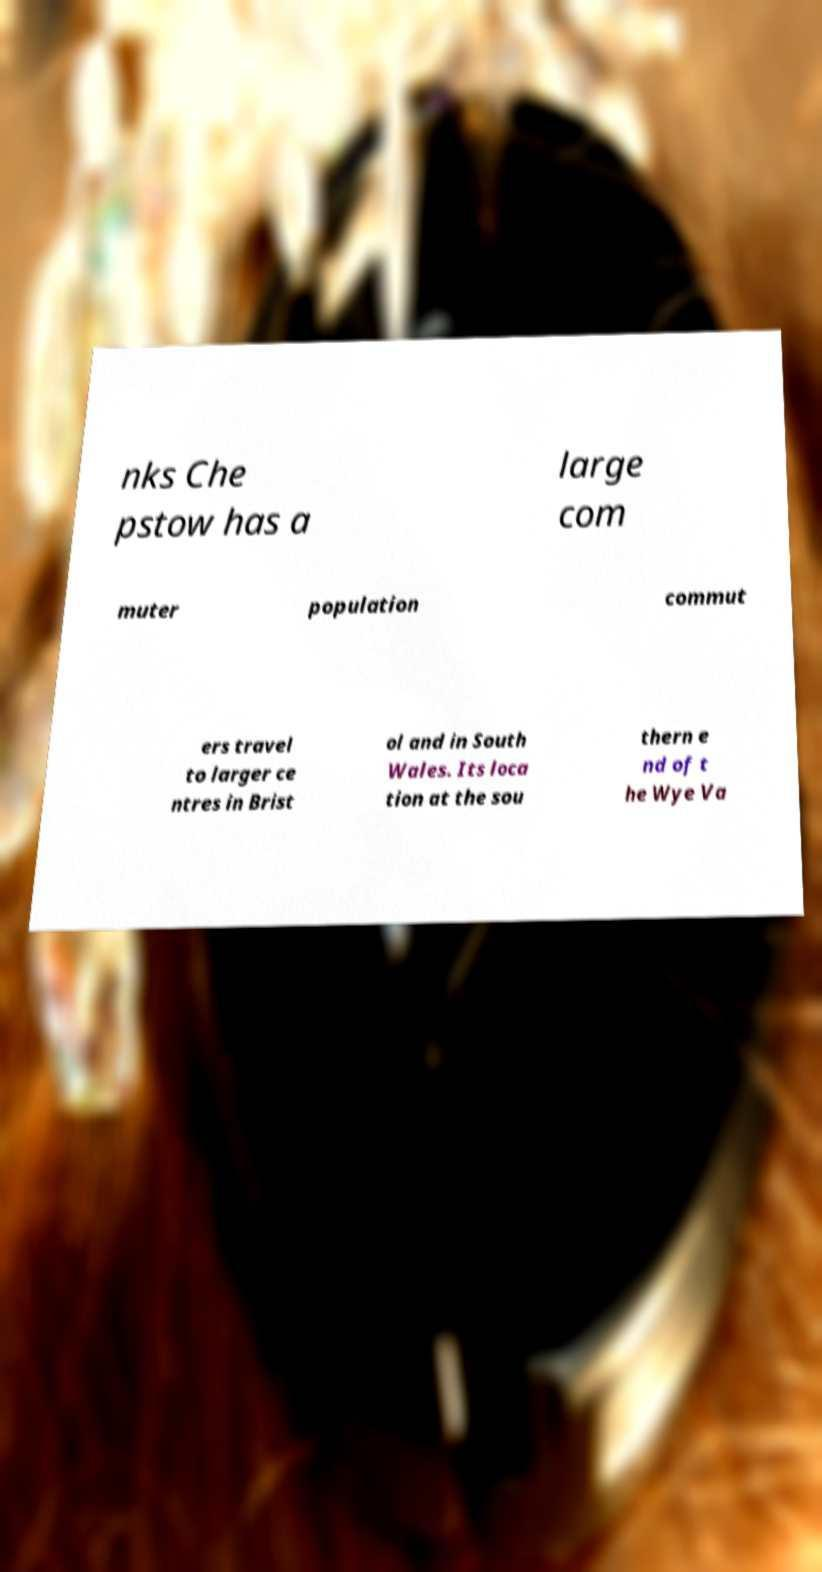Can you read and provide the text displayed in the image?This photo seems to have some interesting text. Can you extract and type it out for me? nks Che pstow has a large com muter population commut ers travel to larger ce ntres in Brist ol and in South Wales. Its loca tion at the sou thern e nd of t he Wye Va 